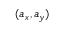<formula> <loc_0><loc_0><loc_500><loc_500>( a _ { x } , a _ { y } )</formula> 